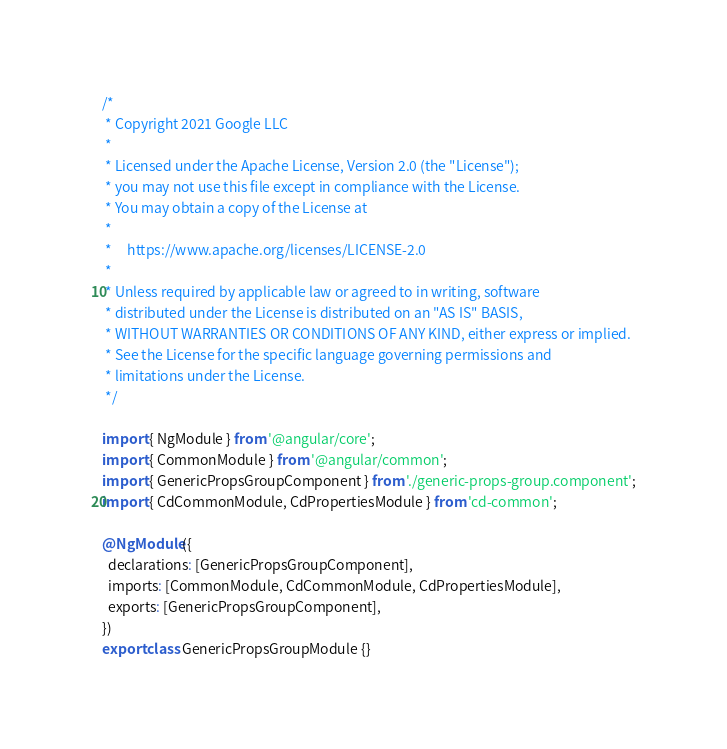Convert code to text. <code><loc_0><loc_0><loc_500><loc_500><_TypeScript_>/*
 * Copyright 2021 Google LLC
 *
 * Licensed under the Apache License, Version 2.0 (the "License");
 * you may not use this file except in compliance with the License.
 * You may obtain a copy of the License at
 *
 *     https://www.apache.org/licenses/LICENSE-2.0
 *
 * Unless required by applicable law or agreed to in writing, software
 * distributed under the License is distributed on an "AS IS" BASIS,
 * WITHOUT WARRANTIES OR CONDITIONS OF ANY KIND, either express or implied.
 * See the License for the specific language governing permissions and
 * limitations under the License.
 */

import { NgModule } from '@angular/core';
import { CommonModule } from '@angular/common';
import { GenericPropsGroupComponent } from './generic-props-group.component';
import { CdCommonModule, CdPropertiesModule } from 'cd-common';

@NgModule({
  declarations: [GenericPropsGroupComponent],
  imports: [CommonModule, CdCommonModule, CdPropertiesModule],
  exports: [GenericPropsGroupComponent],
})
export class GenericPropsGroupModule {}
</code> 